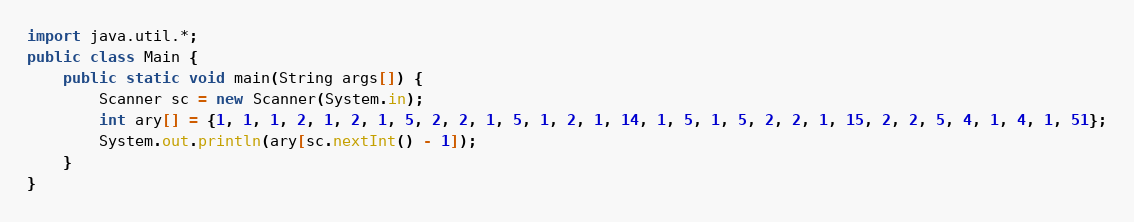<code> <loc_0><loc_0><loc_500><loc_500><_Java_>import java.util.*;
public class Main {
	public static void main(String args[]) {
		Scanner sc = new Scanner(System.in);
		int ary[] = {1, 1, 1, 2, 1, 2, 1, 5, 2, 2, 1, 5, 1, 2, 1, 14, 1, 5, 1, 5, 2, 2, 1, 15, 2, 2, 5, 4, 1, 4, 1, 51};
		System.out.println(ary[sc.nextInt() - 1]);
	}
}
</code> 